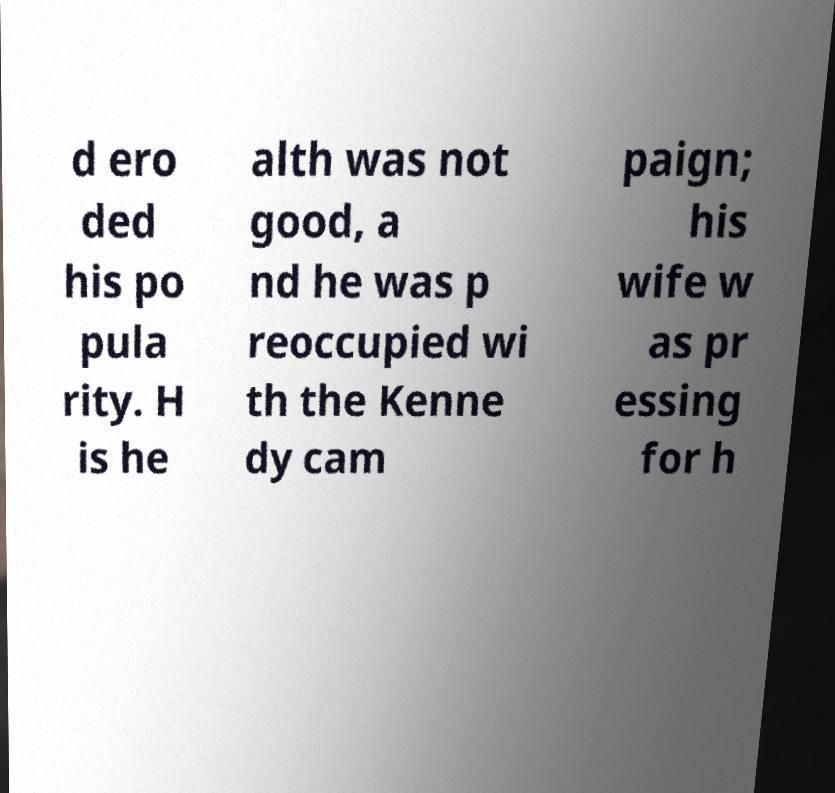Please identify and transcribe the text found in this image. d ero ded his po pula rity. H is he alth was not good, a nd he was p reoccupied wi th the Kenne dy cam paign; his wife w as pr essing for h 